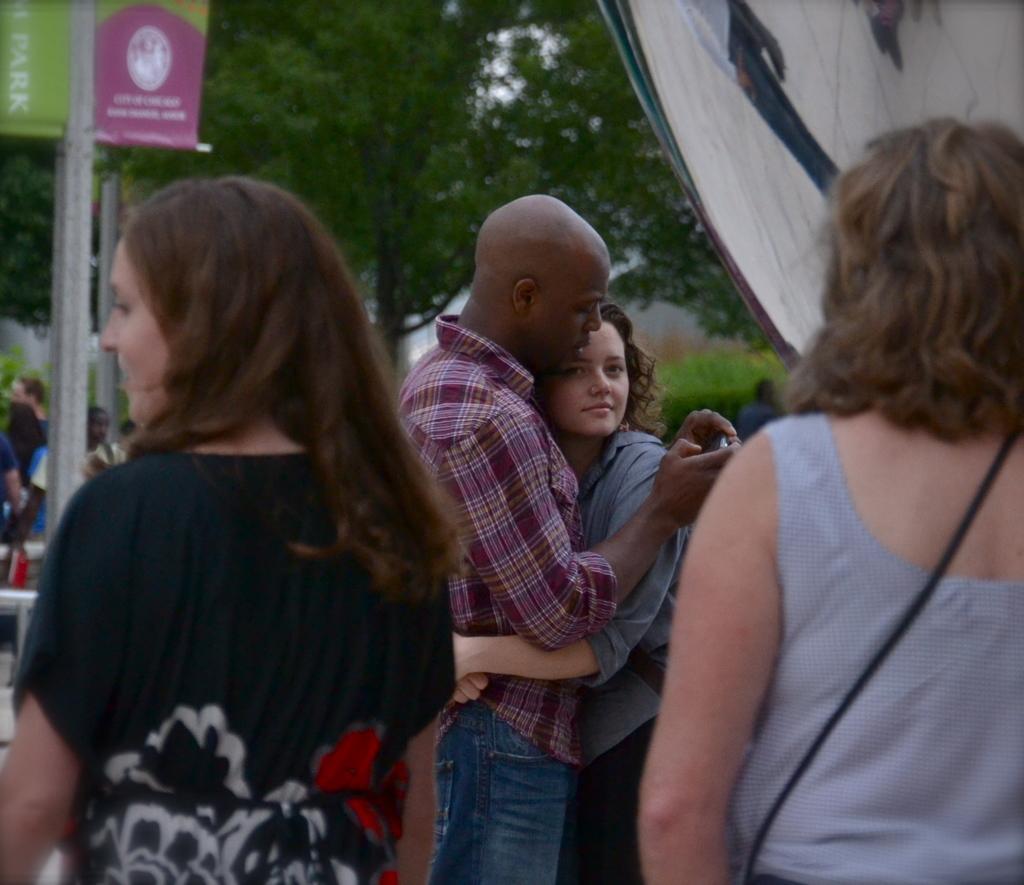Could you give a brief overview of what you see in this image? This image is taken outdoors. In the background there is a tree and there are a few plants. In the middle of the image there are three women and a man and he is holding a mobile phone in his hand. On the left side of the image there is a board with a text on it and there are a few people. 